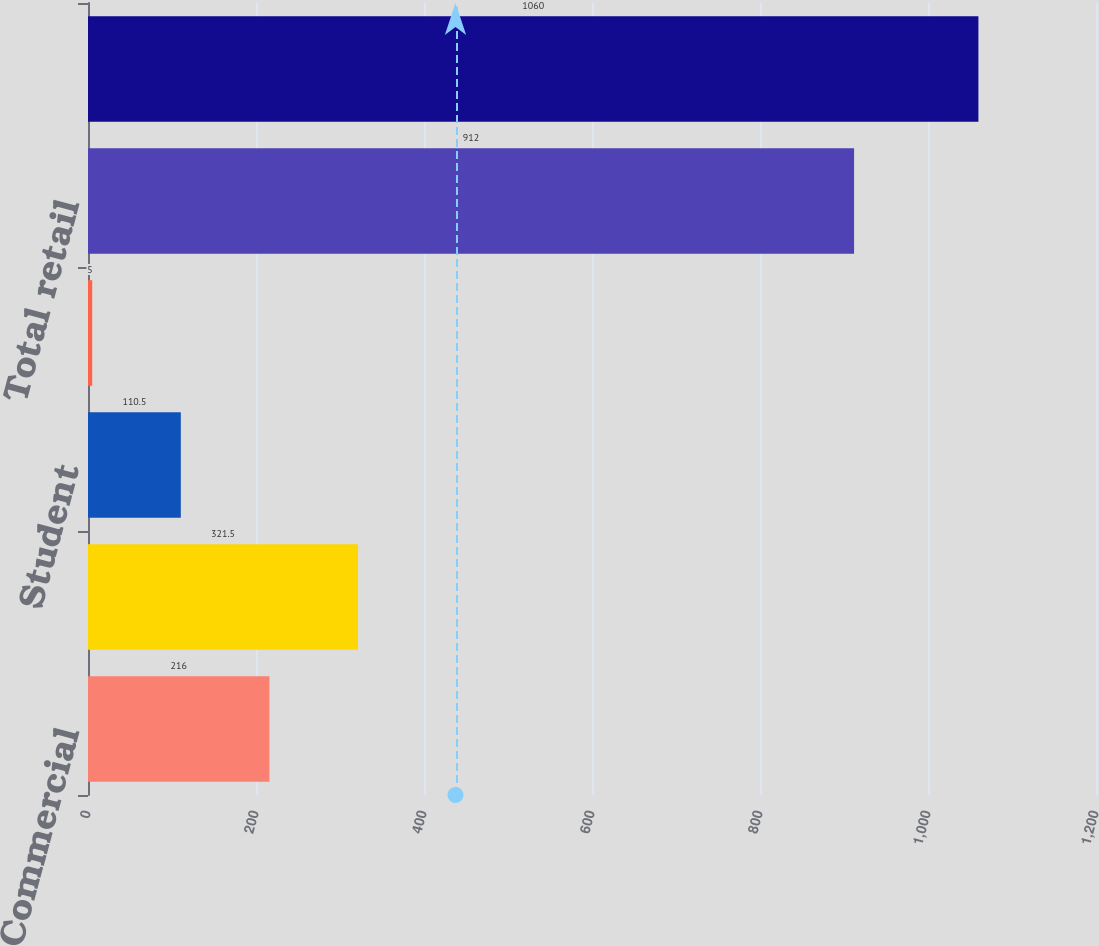<chart> <loc_0><loc_0><loc_500><loc_500><bar_chart><fcel>Commercial<fcel>Total commercial<fcel>Student<fcel>Other retail<fcel>Total retail<fcel>Total<nl><fcel>216<fcel>321.5<fcel>110.5<fcel>5<fcel>912<fcel>1060<nl></chart> 